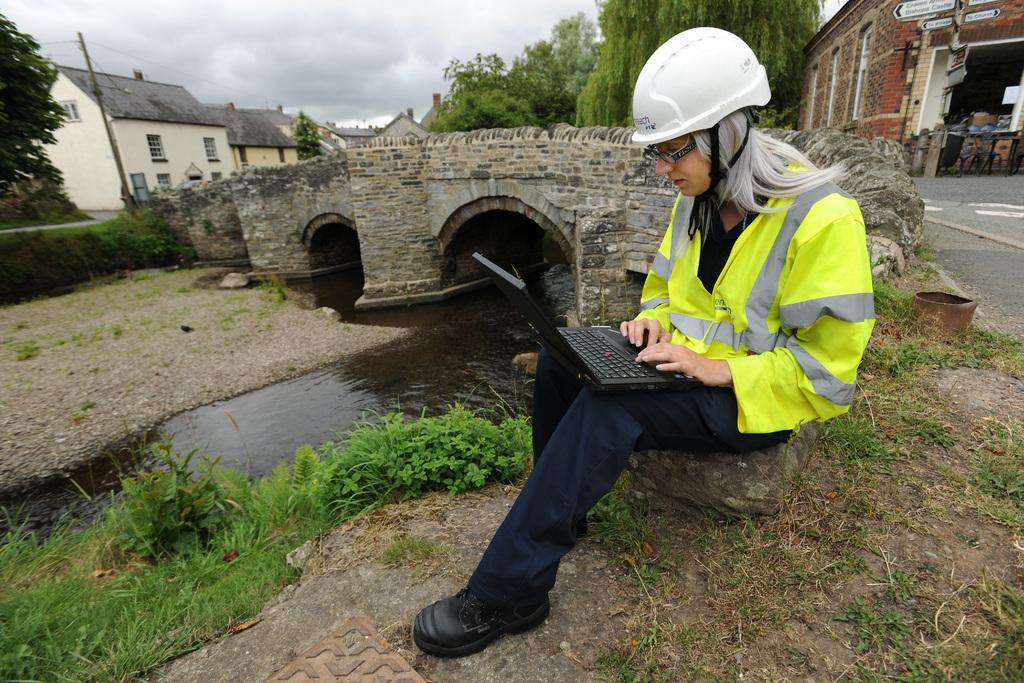How would you summarize this image in a sentence or two? In this image I can see a lady working on the laptop. I can see the water and the grass. In the background, I can see some houses, trees and clouds in the sky. 